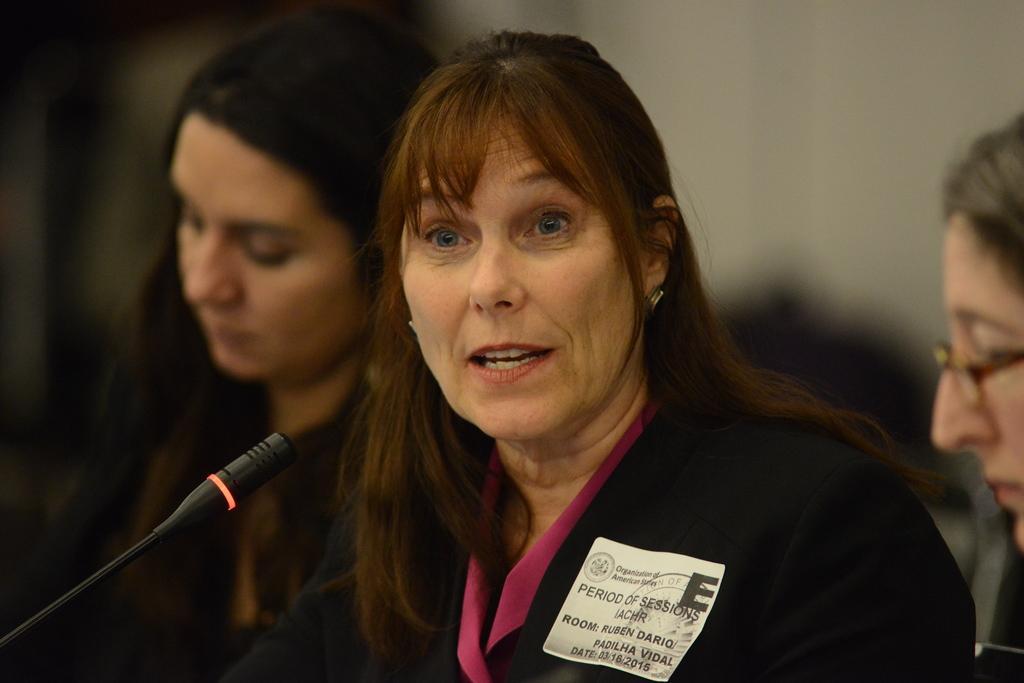Please provide a concise description of this image. In this image there is a woman in the middle. There is a mic in front of her. There is a badge to her coat. There are two other women on either side of her. 